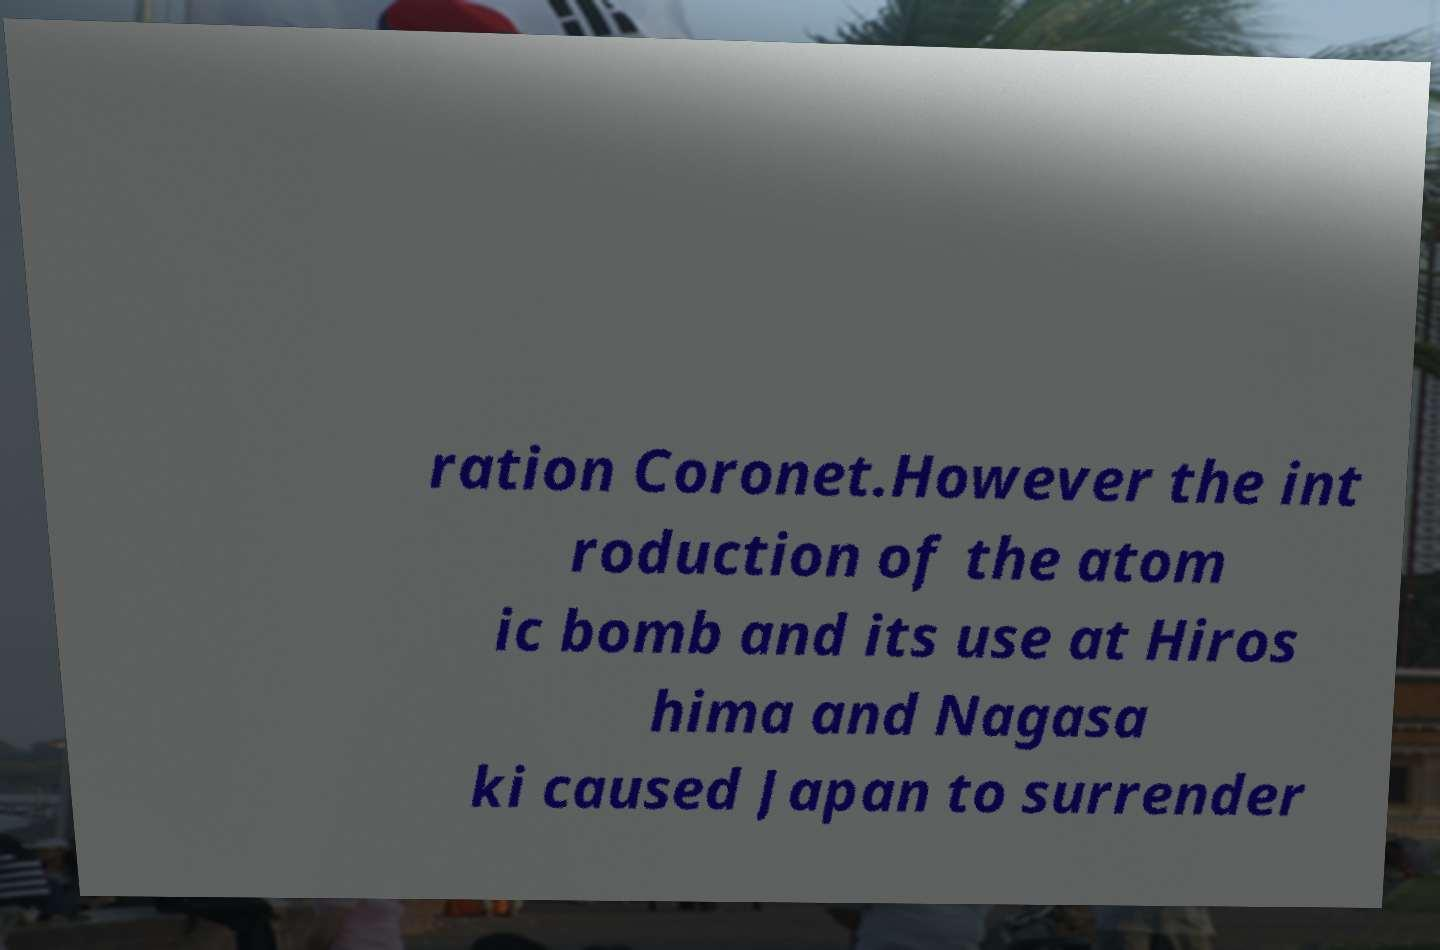Please identify and transcribe the text found in this image. ration Coronet.However the int roduction of the atom ic bomb and its use at Hiros hima and Nagasa ki caused Japan to surrender 